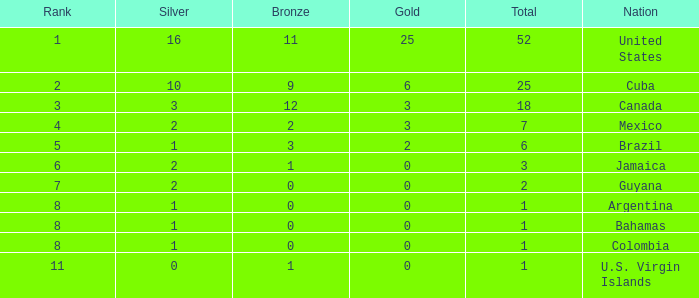What is the fewest number of silver medals a nation who ranked below 8 received? 0.0. 